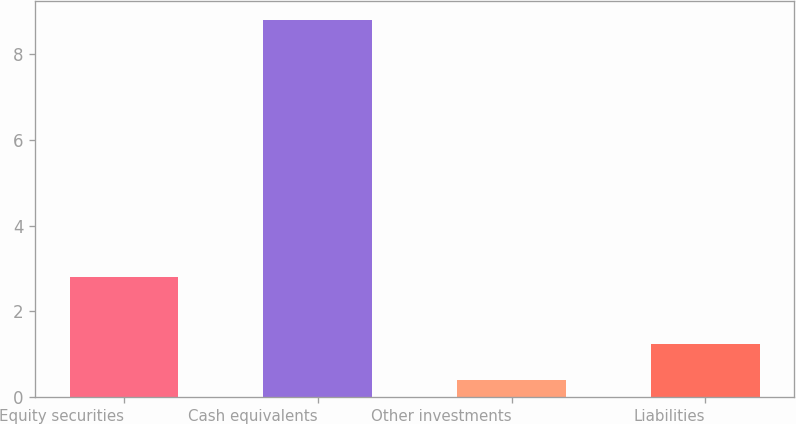<chart> <loc_0><loc_0><loc_500><loc_500><bar_chart><fcel>Equity securities<fcel>Cash equivalents<fcel>Other investments<fcel>Liabilities<nl><fcel>2.8<fcel>8.8<fcel>0.4<fcel>1.24<nl></chart> 